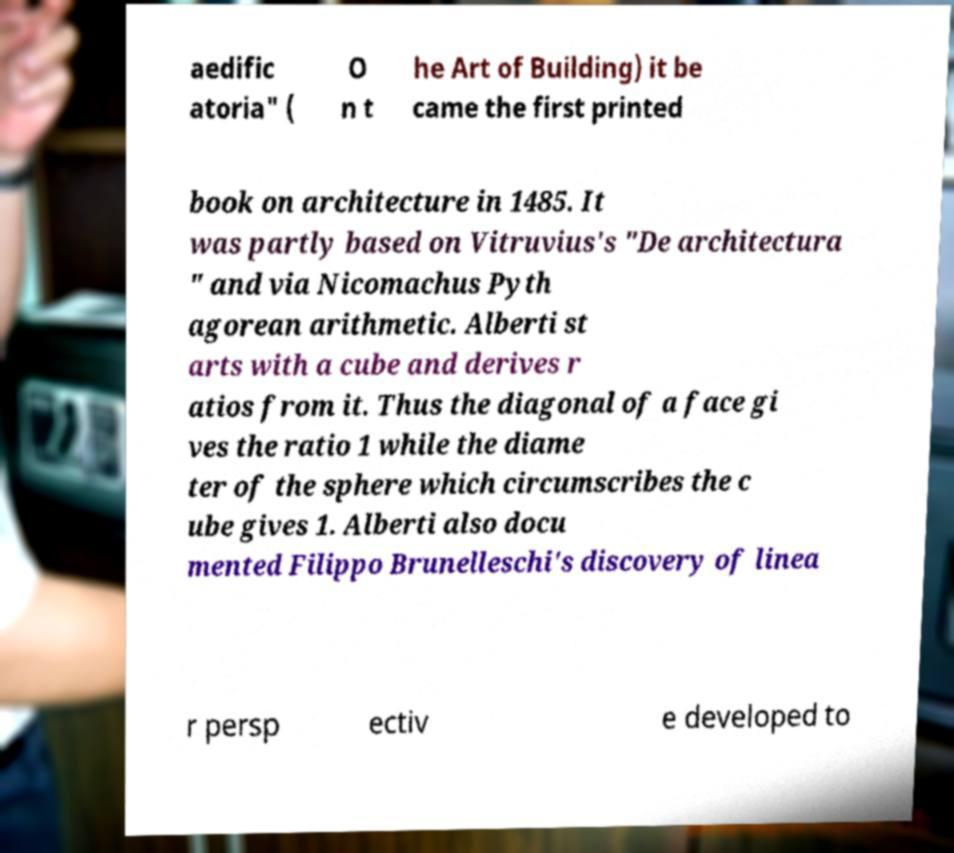I need the written content from this picture converted into text. Can you do that? aedific atoria" ( O n t he Art of Building) it be came the first printed book on architecture in 1485. It was partly based on Vitruvius's "De architectura " and via Nicomachus Pyth agorean arithmetic. Alberti st arts with a cube and derives r atios from it. Thus the diagonal of a face gi ves the ratio 1 while the diame ter of the sphere which circumscribes the c ube gives 1. Alberti also docu mented Filippo Brunelleschi's discovery of linea r persp ectiv e developed to 